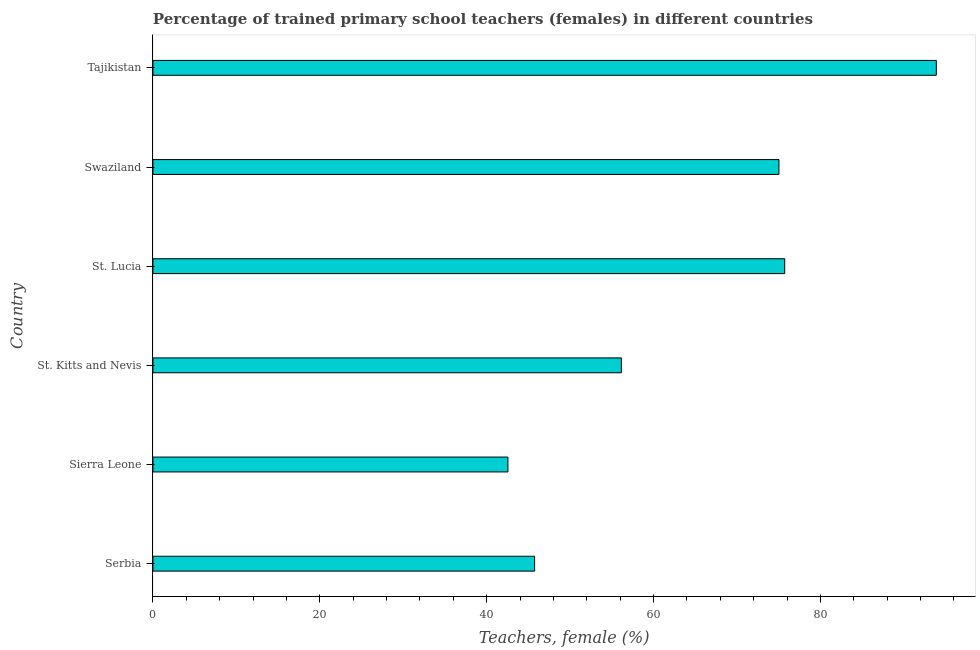Does the graph contain any zero values?
Ensure brevity in your answer.  No. Does the graph contain grids?
Provide a succinct answer. No. What is the title of the graph?
Your answer should be compact. Percentage of trained primary school teachers (females) in different countries. What is the label or title of the X-axis?
Provide a short and direct response. Teachers, female (%). What is the label or title of the Y-axis?
Offer a terse response. Country. What is the percentage of trained female teachers in Swaziland?
Provide a short and direct response. 75.02. Across all countries, what is the maximum percentage of trained female teachers?
Give a very brief answer. 93.88. Across all countries, what is the minimum percentage of trained female teachers?
Provide a short and direct response. 42.55. In which country was the percentage of trained female teachers maximum?
Ensure brevity in your answer.  Tajikistan. In which country was the percentage of trained female teachers minimum?
Offer a very short reply. Sierra Leone. What is the sum of the percentage of trained female teachers?
Offer a terse response. 389.05. What is the difference between the percentage of trained female teachers in Sierra Leone and Tajikistan?
Keep it short and to the point. -51.34. What is the average percentage of trained female teachers per country?
Give a very brief answer. 64.84. What is the median percentage of trained female teachers?
Provide a short and direct response. 65.58. What is the ratio of the percentage of trained female teachers in St. Kitts and Nevis to that in Swaziland?
Ensure brevity in your answer.  0.75. Is the difference between the percentage of trained female teachers in St. Lucia and Tajikistan greater than the difference between any two countries?
Make the answer very short. No. What is the difference between the highest and the second highest percentage of trained female teachers?
Offer a very short reply. 18.17. What is the difference between the highest and the lowest percentage of trained female teachers?
Make the answer very short. 51.34. In how many countries, is the percentage of trained female teachers greater than the average percentage of trained female teachers taken over all countries?
Make the answer very short. 3. How many bars are there?
Ensure brevity in your answer.  6. How many countries are there in the graph?
Your response must be concise. 6. Are the values on the major ticks of X-axis written in scientific E-notation?
Provide a short and direct response. No. What is the Teachers, female (%) in Serbia?
Offer a very short reply. 45.74. What is the Teachers, female (%) of Sierra Leone?
Give a very brief answer. 42.55. What is the Teachers, female (%) in St. Kitts and Nevis?
Ensure brevity in your answer.  56.14. What is the Teachers, female (%) in St. Lucia?
Provide a short and direct response. 75.71. What is the Teachers, female (%) of Swaziland?
Ensure brevity in your answer.  75.02. What is the Teachers, female (%) in Tajikistan?
Ensure brevity in your answer.  93.88. What is the difference between the Teachers, female (%) in Serbia and Sierra Leone?
Your answer should be very brief. 3.2. What is the difference between the Teachers, female (%) in Serbia and St. Kitts and Nevis?
Provide a succinct answer. -10.4. What is the difference between the Teachers, female (%) in Serbia and St. Lucia?
Provide a succinct answer. -29.97. What is the difference between the Teachers, female (%) in Serbia and Swaziland?
Offer a terse response. -29.28. What is the difference between the Teachers, female (%) in Serbia and Tajikistan?
Provide a succinct answer. -48.14. What is the difference between the Teachers, female (%) in Sierra Leone and St. Kitts and Nevis?
Offer a terse response. -13.6. What is the difference between the Teachers, female (%) in Sierra Leone and St. Lucia?
Give a very brief answer. -33.17. What is the difference between the Teachers, female (%) in Sierra Leone and Swaziland?
Provide a succinct answer. -32.48. What is the difference between the Teachers, female (%) in Sierra Leone and Tajikistan?
Keep it short and to the point. -51.34. What is the difference between the Teachers, female (%) in St. Kitts and Nevis and St. Lucia?
Offer a very short reply. -19.57. What is the difference between the Teachers, female (%) in St. Kitts and Nevis and Swaziland?
Your response must be concise. -18.88. What is the difference between the Teachers, female (%) in St. Kitts and Nevis and Tajikistan?
Your answer should be very brief. -37.74. What is the difference between the Teachers, female (%) in St. Lucia and Swaziland?
Ensure brevity in your answer.  0.69. What is the difference between the Teachers, female (%) in St. Lucia and Tajikistan?
Provide a succinct answer. -18.17. What is the difference between the Teachers, female (%) in Swaziland and Tajikistan?
Give a very brief answer. -18.86. What is the ratio of the Teachers, female (%) in Serbia to that in Sierra Leone?
Provide a succinct answer. 1.07. What is the ratio of the Teachers, female (%) in Serbia to that in St. Kitts and Nevis?
Provide a short and direct response. 0.81. What is the ratio of the Teachers, female (%) in Serbia to that in St. Lucia?
Give a very brief answer. 0.6. What is the ratio of the Teachers, female (%) in Serbia to that in Swaziland?
Make the answer very short. 0.61. What is the ratio of the Teachers, female (%) in Serbia to that in Tajikistan?
Your answer should be very brief. 0.49. What is the ratio of the Teachers, female (%) in Sierra Leone to that in St. Kitts and Nevis?
Make the answer very short. 0.76. What is the ratio of the Teachers, female (%) in Sierra Leone to that in St. Lucia?
Offer a terse response. 0.56. What is the ratio of the Teachers, female (%) in Sierra Leone to that in Swaziland?
Your answer should be very brief. 0.57. What is the ratio of the Teachers, female (%) in Sierra Leone to that in Tajikistan?
Provide a succinct answer. 0.45. What is the ratio of the Teachers, female (%) in St. Kitts and Nevis to that in St. Lucia?
Your response must be concise. 0.74. What is the ratio of the Teachers, female (%) in St. Kitts and Nevis to that in Swaziland?
Your response must be concise. 0.75. What is the ratio of the Teachers, female (%) in St. Kitts and Nevis to that in Tajikistan?
Offer a very short reply. 0.6. What is the ratio of the Teachers, female (%) in St. Lucia to that in Tajikistan?
Provide a short and direct response. 0.81. What is the ratio of the Teachers, female (%) in Swaziland to that in Tajikistan?
Ensure brevity in your answer.  0.8. 